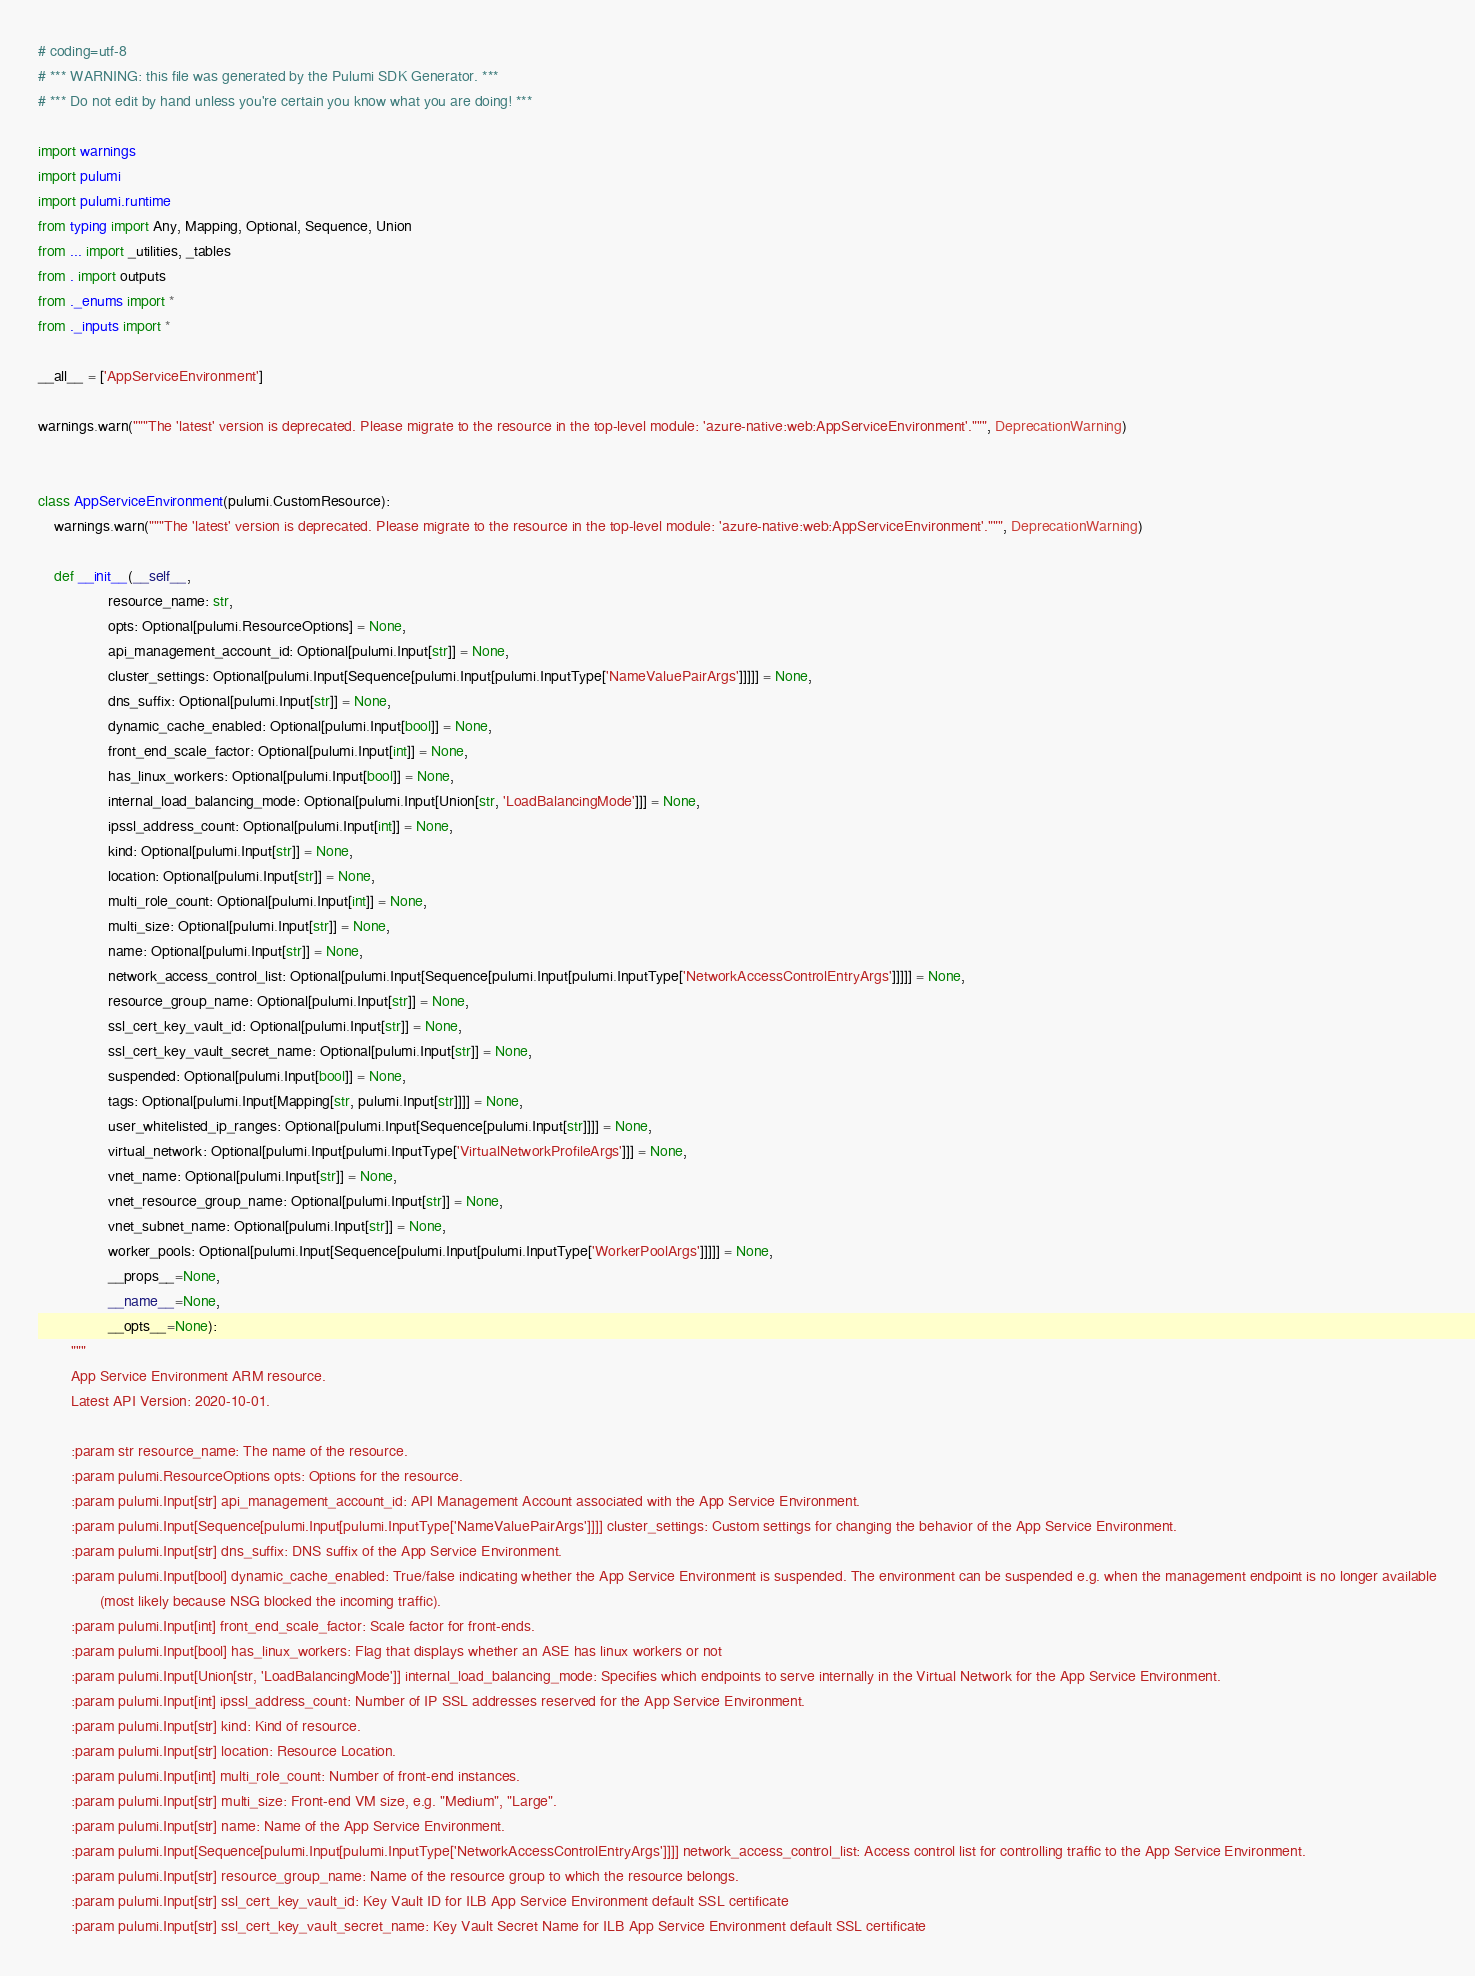Convert code to text. <code><loc_0><loc_0><loc_500><loc_500><_Python_># coding=utf-8
# *** WARNING: this file was generated by the Pulumi SDK Generator. ***
# *** Do not edit by hand unless you're certain you know what you are doing! ***

import warnings
import pulumi
import pulumi.runtime
from typing import Any, Mapping, Optional, Sequence, Union
from ... import _utilities, _tables
from . import outputs
from ._enums import *
from ._inputs import *

__all__ = ['AppServiceEnvironment']

warnings.warn("""The 'latest' version is deprecated. Please migrate to the resource in the top-level module: 'azure-native:web:AppServiceEnvironment'.""", DeprecationWarning)


class AppServiceEnvironment(pulumi.CustomResource):
    warnings.warn("""The 'latest' version is deprecated. Please migrate to the resource in the top-level module: 'azure-native:web:AppServiceEnvironment'.""", DeprecationWarning)

    def __init__(__self__,
                 resource_name: str,
                 opts: Optional[pulumi.ResourceOptions] = None,
                 api_management_account_id: Optional[pulumi.Input[str]] = None,
                 cluster_settings: Optional[pulumi.Input[Sequence[pulumi.Input[pulumi.InputType['NameValuePairArgs']]]]] = None,
                 dns_suffix: Optional[pulumi.Input[str]] = None,
                 dynamic_cache_enabled: Optional[pulumi.Input[bool]] = None,
                 front_end_scale_factor: Optional[pulumi.Input[int]] = None,
                 has_linux_workers: Optional[pulumi.Input[bool]] = None,
                 internal_load_balancing_mode: Optional[pulumi.Input[Union[str, 'LoadBalancingMode']]] = None,
                 ipssl_address_count: Optional[pulumi.Input[int]] = None,
                 kind: Optional[pulumi.Input[str]] = None,
                 location: Optional[pulumi.Input[str]] = None,
                 multi_role_count: Optional[pulumi.Input[int]] = None,
                 multi_size: Optional[pulumi.Input[str]] = None,
                 name: Optional[pulumi.Input[str]] = None,
                 network_access_control_list: Optional[pulumi.Input[Sequence[pulumi.Input[pulumi.InputType['NetworkAccessControlEntryArgs']]]]] = None,
                 resource_group_name: Optional[pulumi.Input[str]] = None,
                 ssl_cert_key_vault_id: Optional[pulumi.Input[str]] = None,
                 ssl_cert_key_vault_secret_name: Optional[pulumi.Input[str]] = None,
                 suspended: Optional[pulumi.Input[bool]] = None,
                 tags: Optional[pulumi.Input[Mapping[str, pulumi.Input[str]]]] = None,
                 user_whitelisted_ip_ranges: Optional[pulumi.Input[Sequence[pulumi.Input[str]]]] = None,
                 virtual_network: Optional[pulumi.Input[pulumi.InputType['VirtualNetworkProfileArgs']]] = None,
                 vnet_name: Optional[pulumi.Input[str]] = None,
                 vnet_resource_group_name: Optional[pulumi.Input[str]] = None,
                 vnet_subnet_name: Optional[pulumi.Input[str]] = None,
                 worker_pools: Optional[pulumi.Input[Sequence[pulumi.Input[pulumi.InputType['WorkerPoolArgs']]]]] = None,
                 __props__=None,
                 __name__=None,
                 __opts__=None):
        """
        App Service Environment ARM resource.
        Latest API Version: 2020-10-01.

        :param str resource_name: The name of the resource.
        :param pulumi.ResourceOptions opts: Options for the resource.
        :param pulumi.Input[str] api_management_account_id: API Management Account associated with the App Service Environment.
        :param pulumi.Input[Sequence[pulumi.Input[pulumi.InputType['NameValuePairArgs']]]] cluster_settings: Custom settings for changing the behavior of the App Service Environment.
        :param pulumi.Input[str] dns_suffix: DNS suffix of the App Service Environment.
        :param pulumi.Input[bool] dynamic_cache_enabled: True/false indicating whether the App Service Environment is suspended. The environment can be suspended e.g. when the management endpoint is no longer available
               (most likely because NSG blocked the incoming traffic).
        :param pulumi.Input[int] front_end_scale_factor: Scale factor for front-ends.
        :param pulumi.Input[bool] has_linux_workers: Flag that displays whether an ASE has linux workers or not
        :param pulumi.Input[Union[str, 'LoadBalancingMode']] internal_load_balancing_mode: Specifies which endpoints to serve internally in the Virtual Network for the App Service Environment.
        :param pulumi.Input[int] ipssl_address_count: Number of IP SSL addresses reserved for the App Service Environment.
        :param pulumi.Input[str] kind: Kind of resource.
        :param pulumi.Input[str] location: Resource Location.
        :param pulumi.Input[int] multi_role_count: Number of front-end instances.
        :param pulumi.Input[str] multi_size: Front-end VM size, e.g. "Medium", "Large".
        :param pulumi.Input[str] name: Name of the App Service Environment.
        :param pulumi.Input[Sequence[pulumi.Input[pulumi.InputType['NetworkAccessControlEntryArgs']]]] network_access_control_list: Access control list for controlling traffic to the App Service Environment.
        :param pulumi.Input[str] resource_group_name: Name of the resource group to which the resource belongs.
        :param pulumi.Input[str] ssl_cert_key_vault_id: Key Vault ID for ILB App Service Environment default SSL certificate
        :param pulumi.Input[str] ssl_cert_key_vault_secret_name: Key Vault Secret Name for ILB App Service Environment default SSL certificate</code> 